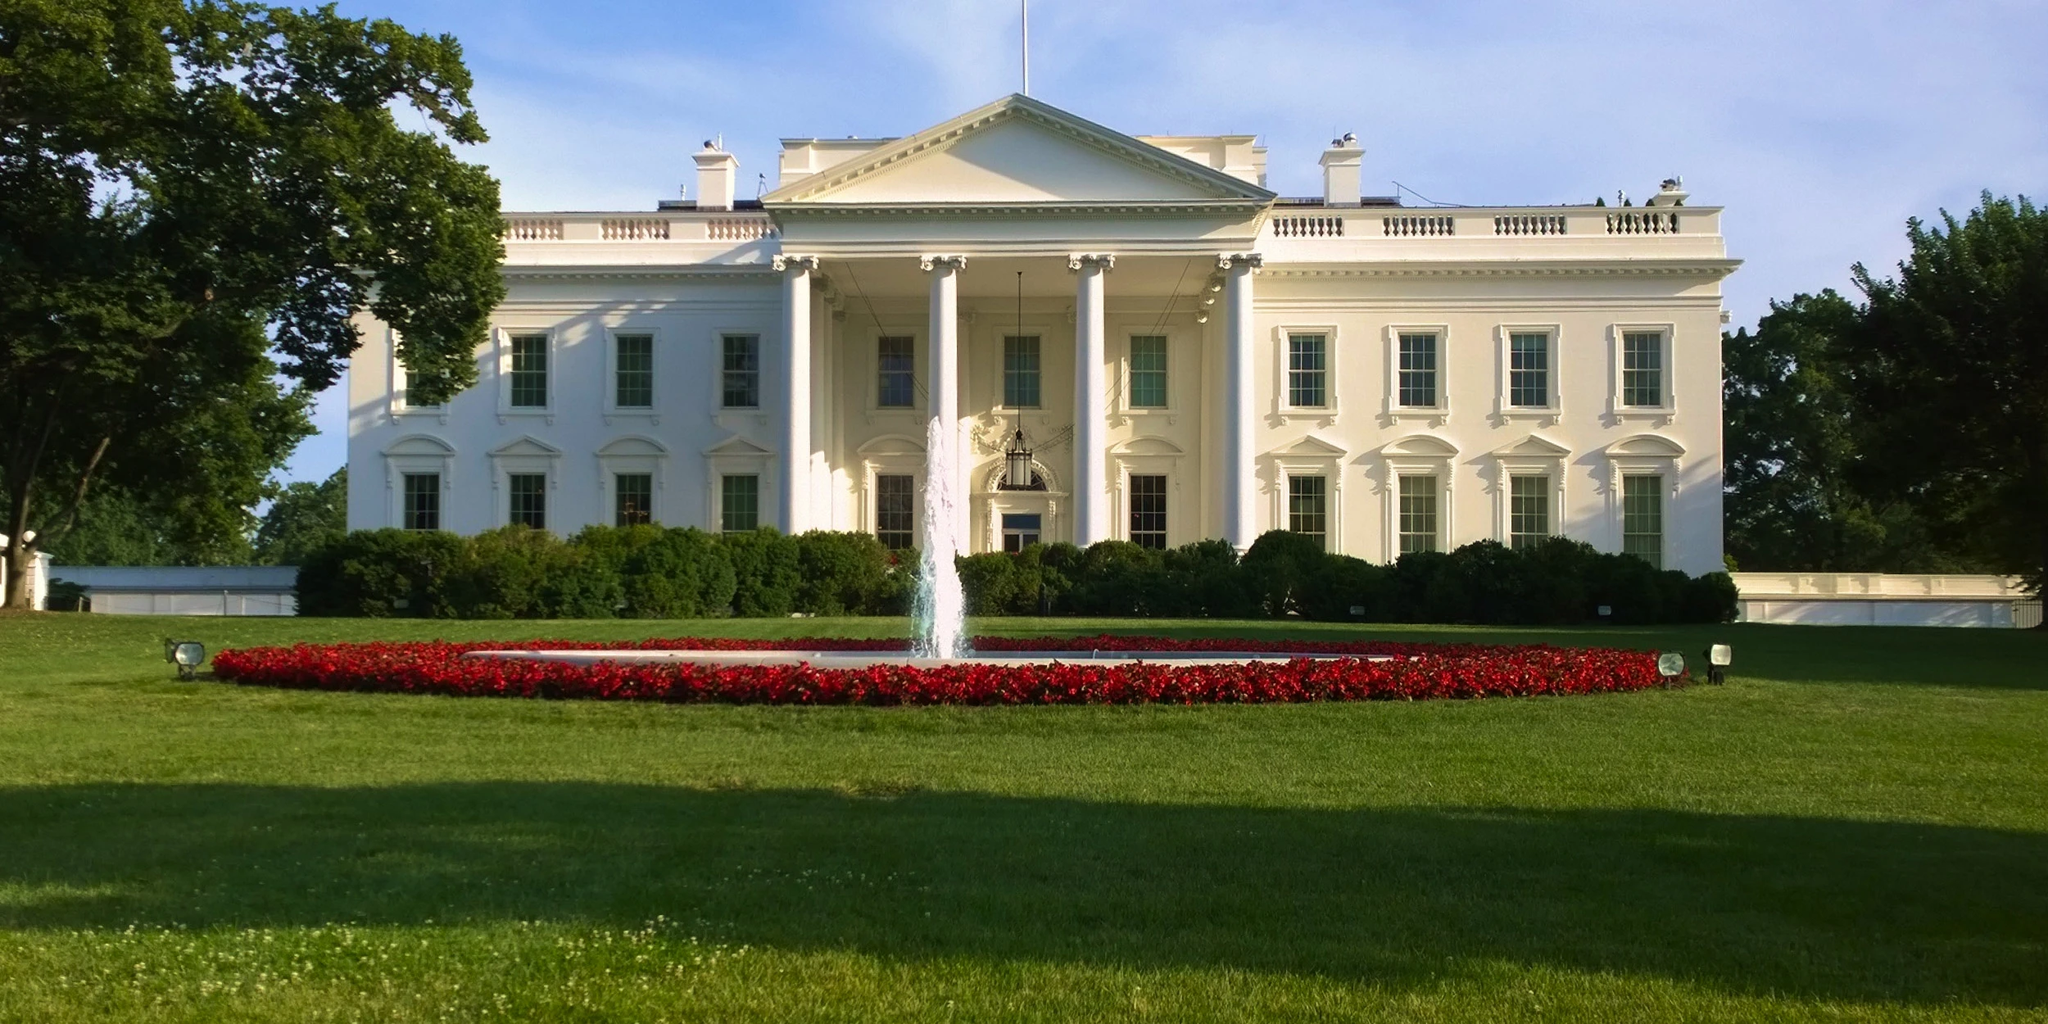What events are typically held at this location? The White House hosts a variety of significant events each year ranging from state ceremonies and national celebrations, such as the Fourth of July, to public gatherings like the annual Easter Egg Roll. Additionally, it frequently serves as a venue for important diplomatic meetings, press conferences, and as a stage for the President to address the nation during moments of national importance. 